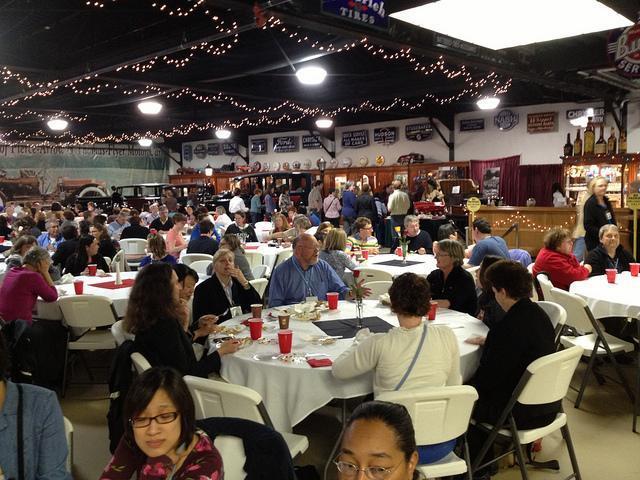How many dining tables are in the picture?
Give a very brief answer. 3. How many people can be seen?
Give a very brief answer. 9. How many chairs can you see?
Give a very brief answer. 5. How many giraffes are there?
Give a very brief answer. 0. 